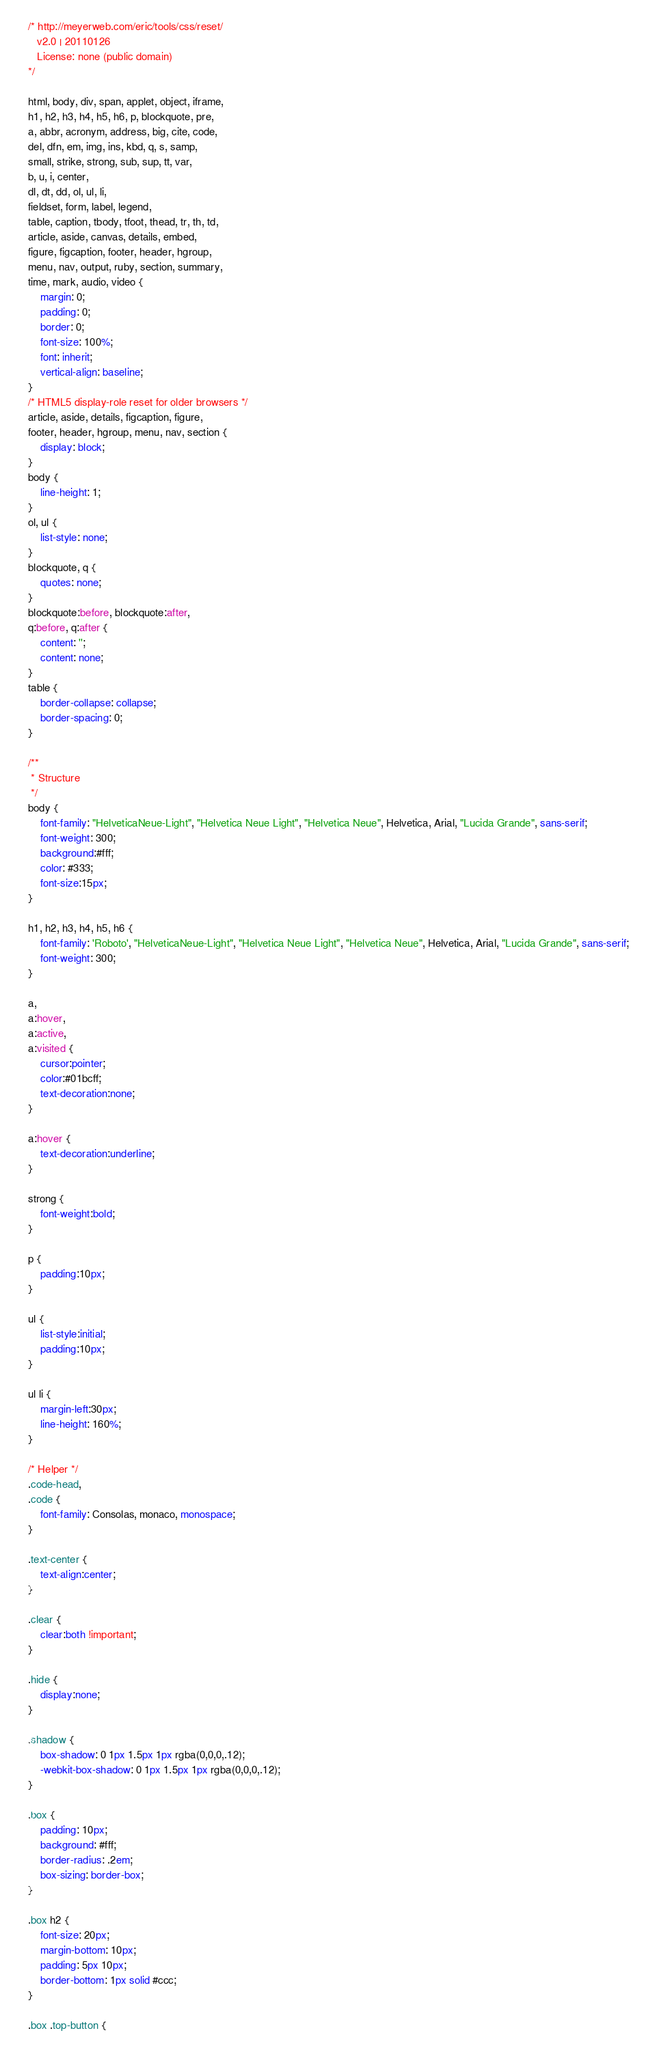<code> <loc_0><loc_0><loc_500><loc_500><_CSS_>/* http://meyerweb.com/eric/tools/css/reset/
   v2.0 | 20110126
   License: none (public domain)
*/

html, body, div, span, applet, object, iframe,
h1, h2, h3, h4, h5, h6, p, blockquote, pre,
a, abbr, acronym, address, big, cite, code,
del, dfn, em, img, ins, kbd, q, s, samp,
small, strike, strong, sub, sup, tt, var,
b, u, i, center,
dl, dt, dd, ol, ul, li,
fieldset, form, label, legend,
table, caption, tbody, tfoot, thead, tr, th, td,
article, aside, canvas, details, embed,
figure, figcaption, footer, header, hgroup,
menu, nav, output, ruby, section, summary,
time, mark, audio, video {
    margin: 0;
    padding: 0;
    border: 0;
    font-size: 100%;
    font: inherit;
    vertical-align: baseline;
}
/* HTML5 display-role reset for older browsers */
article, aside, details, figcaption, figure,
footer, header, hgroup, menu, nav, section {
    display: block;
}
body {
    line-height: 1;
}
ol, ul {
    list-style: none;
}
blockquote, q {
    quotes: none;
}
blockquote:before, blockquote:after,
q:before, q:after {
    content: '';
    content: none;
}
table {
    border-collapse: collapse;
    border-spacing: 0;
}

/**
 * Structure
 */
body {
    font-family: "HelveticaNeue-Light", "Helvetica Neue Light", "Helvetica Neue", Helvetica, Arial, "Lucida Grande", sans-serif;
    font-weight: 300;
    background:#fff;
    color: #333;
    font-size:15px;
}

h1, h2, h3, h4, h5, h6 {
    font-family: 'Roboto', "HelveticaNeue-Light", "Helvetica Neue Light", "Helvetica Neue", Helvetica, Arial, "Lucida Grande", sans-serif;
    font-weight: 300;
}

a,
a:hover,
a:active,
a:visited {
    cursor:pointer;
    color:#01bcff;
    text-decoration:none;
}

a:hover {
    text-decoration:underline;
}

strong {
    font-weight:bold;
}

p {
    padding:10px;
}

ul {
    list-style:initial;
    padding:10px;
}

ul li {
    margin-left:30px;
    line-height: 160%;
}

/* Helper */
.code-head,
.code {
    font-family: Consolas, monaco, monospace;
}

.text-center {
    text-align:center;
}

.clear {
    clear:both !important;
}

.hide {
    display:none;
}

.shadow {
    box-shadow: 0 1px 1.5px 1px rgba(0,0,0,.12);
    -webkit-box-shadow: 0 1px 1.5px 1px rgba(0,0,0,.12);
}

.box {
    padding: 10px;
    background: #fff;
    border-radius: .2em;
    box-sizing: border-box;
}

.box h2 {
    font-size: 20px;
    margin-bottom: 10px;
    padding: 5px 10px;
    border-bottom: 1px solid #ccc;
}

.box .top-button {</code> 